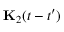<formula> <loc_0><loc_0><loc_500><loc_500>{ K } _ { 2 } ( t - t ^ { \prime } )</formula> 